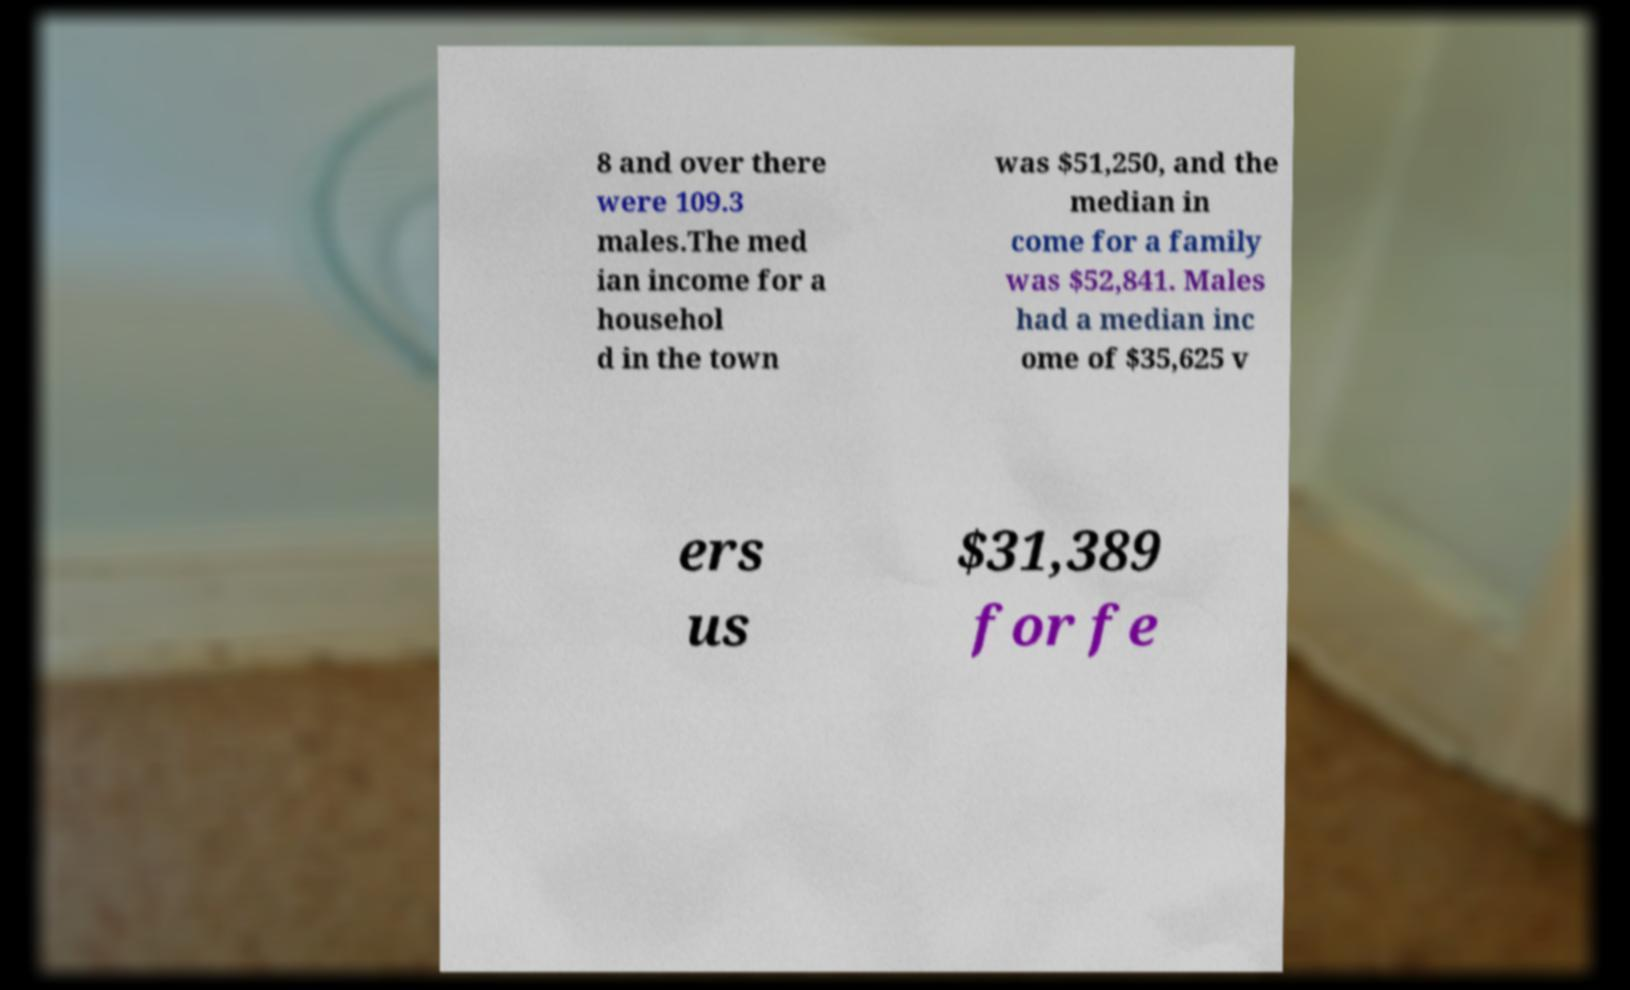What messages or text are displayed in this image? I need them in a readable, typed format. 8 and over there were 109.3 males.The med ian income for a househol d in the town was $51,250, and the median in come for a family was $52,841. Males had a median inc ome of $35,625 v ers us $31,389 for fe 